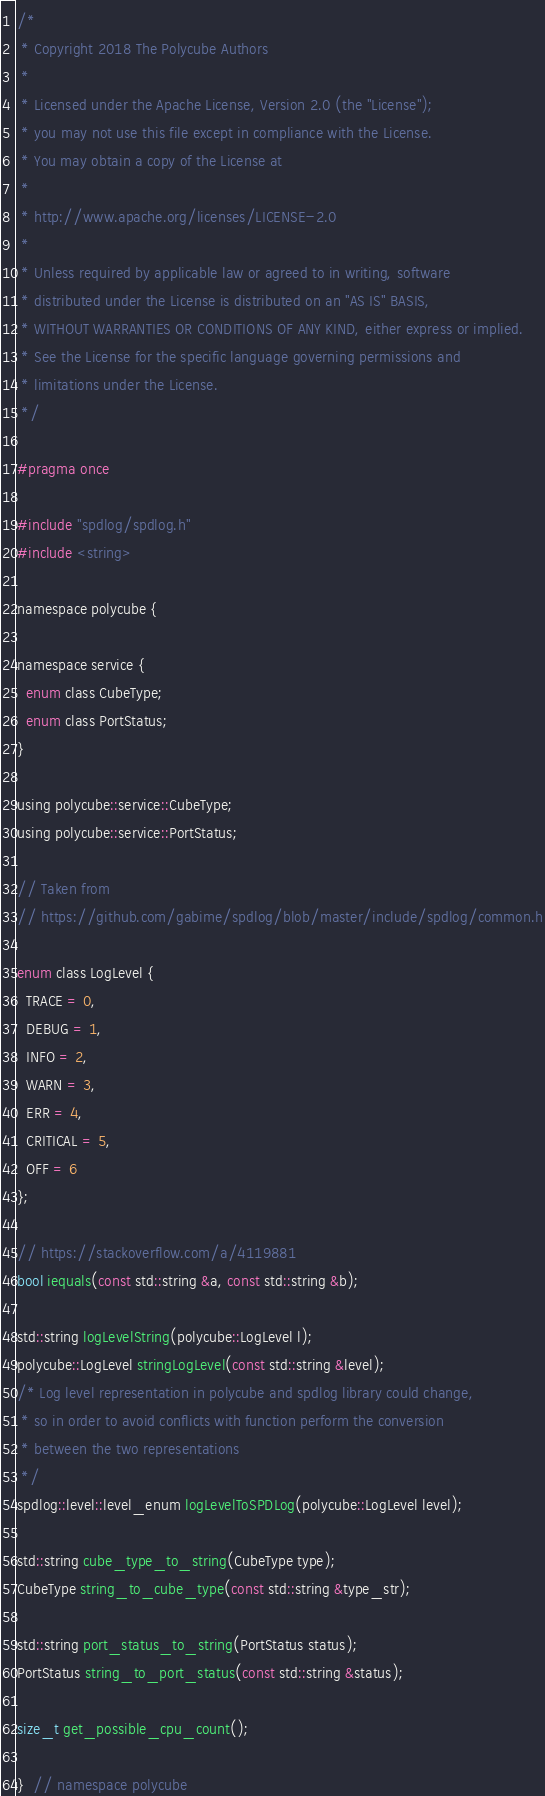<code> <loc_0><loc_0><loc_500><loc_500><_C_>/*
 * Copyright 2018 The Polycube Authors
 *
 * Licensed under the Apache License, Version 2.0 (the "License");
 * you may not use this file except in compliance with the License.
 * You may obtain a copy of the License at
 *
 * http://www.apache.org/licenses/LICENSE-2.0
 *
 * Unless required by applicable law or agreed to in writing, software
 * distributed under the License is distributed on an "AS IS" BASIS,
 * WITHOUT WARRANTIES OR CONDITIONS OF ANY KIND, either express or implied.
 * See the License for the specific language governing permissions and
 * limitations under the License.
 */

#pragma once

#include "spdlog/spdlog.h"
#include <string>

namespace polycube {

namespace service {
  enum class CubeType;
  enum class PortStatus;
}

using polycube::service::CubeType;
using polycube::service::PortStatus;

// Taken from
// https://github.com/gabime/spdlog/blob/master/include/spdlog/common.h

enum class LogLevel {
  TRACE = 0,
  DEBUG = 1,
  INFO = 2,
  WARN = 3,
  ERR = 4,
  CRITICAL = 5,
  OFF = 6
};

// https://stackoverflow.com/a/4119881
bool iequals(const std::string &a, const std::string &b);

std::string logLevelString(polycube::LogLevel l);
polycube::LogLevel stringLogLevel(const std::string &level);
/* Log level representation in polycube and spdlog library could change,
 * so in order to avoid conflicts with function perform the conversion
 * between the two representations
 */
spdlog::level::level_enum logLevelToSPDLog(polycube::LogLevel level);

std::string cube_type_to_string(CubeType type);
CubeType string_to_cube_type(const std::string &type_str);

std::string port_status_to_string(PortStatus status);
PortStatus string_to_port_status(const std::string &status);

size_t get_possible_cpu_count();

}  // namespace polycube
</code> 